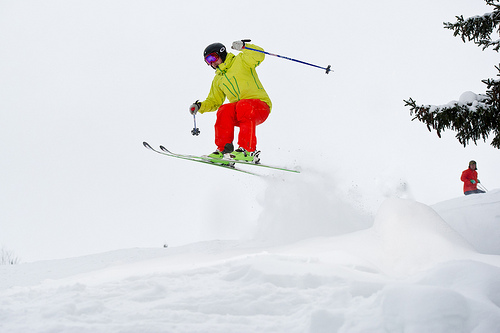Please provide the bounding box coordinate of the region this sentence describes: neon orange ski pants. The neon orange ski pants, enveloping the skier's lower body as they perform a jump, are encapsulated by the bounding box [0.41, 0.36, 0.58, 0.49]. 